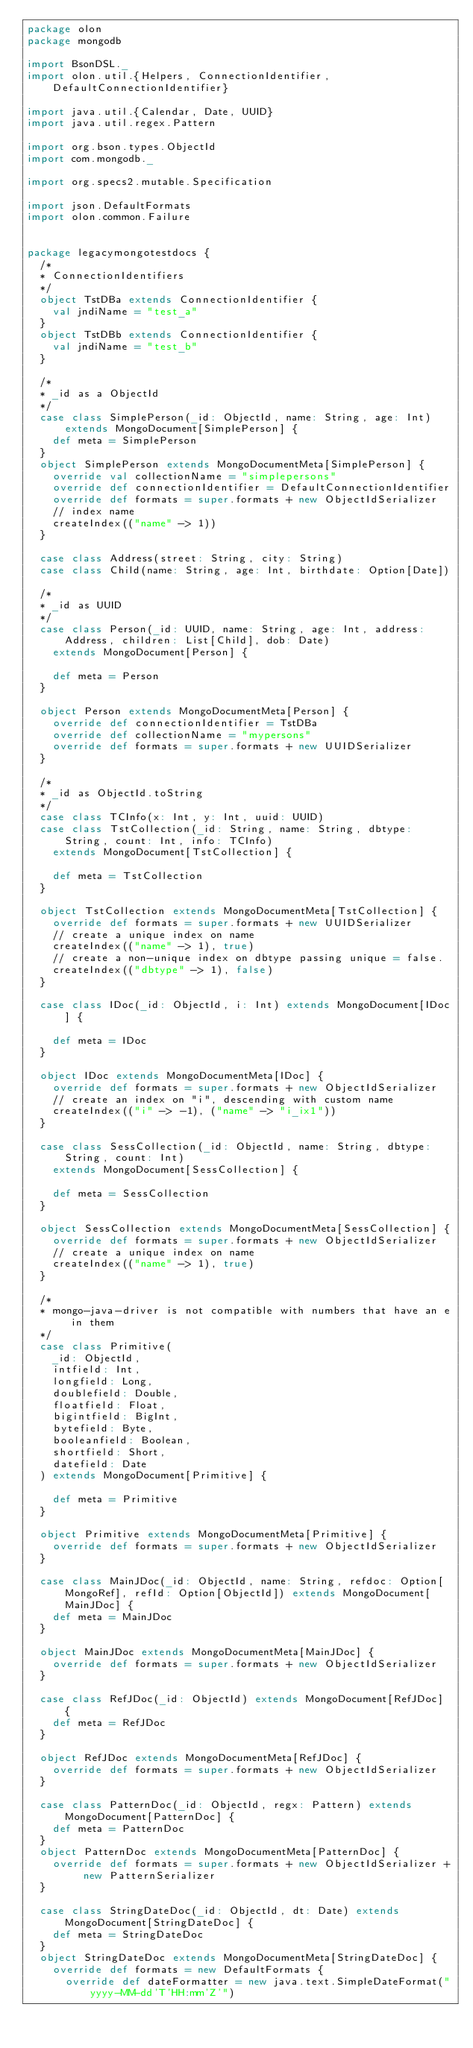<code> <loc_0><loc_0><loc_500><loc_500><_Scala_>package olon
package mongodb

import BsonDSL._
import olon.util.{Helpers, ConnectionIdentifier, DefaultConnectionIdentifier}

import java.util.{Calendar, Date, UUID}
import java.util.regex.Pattern

import org.bson.types.ObjectId
import com.mongodb._

import org.specs2.mutable.Specification

import json.DefaultFormats
import olon.common.Failure


package legacymongotestdocs {
  /*
  * ConnectionIdentifiers
  */
  object TstDBa extends ConnectionIdentifier {
    val jndiName = "test_a"
  }
  object TstDBb extends ConnectionIdentifier {
    val jndiName = "test_b"
  }

  /*
  * _id as a ObjectId
  */
  case class SimplePerson(_id: ObjectId, name: String, age: Int) extends MongoDocument[SimplePerson] {
    def meta = SimplePerson
  }
  object SimplePerson extends MongoDocumentMeta[SimplePerson] {
    override val collectionName = "simplepersons"
    override def connectionIdentifier = DefaultConnectionIdentifier
    override def formats = super.formats + new ObjectIdSerializer
    // index name
    createIndex(("name" -> 1))
  }

  case class Address(street: String, city: String)
  case class Child(name: String, age: Int, birthdate: Option[Date])

  /*
  * _id as UUID
  */
  case class Person(_id: UUID, name: String, age: Int, address: Address, children: List[Child], dob: Date)
    extends MongoDocument[Person] {

    def meta = Person
  }

  object Person extends MongoDocumentMeta[Person] {
    override def connectionIdentifier = TstDBa
    override def collectionName = "mypersons"
    override def formats = super.formats + new UUIDSerializer
  }

  /*
  * _id as ObjectId.toString
  */
  case class TCInfo(x: Int, y: Int, uuid: UUID)
  case class TstCollection(_id: String, name: String, dbtype: String, count: Int, info: TCInfo)
    extends MongoDocument[TstCollection] {

    def meta = TstCollection
  }

  object TstCollection extends MongoDocumentMeta[TstCollection] {
    override def formats = super.formats + new UUIDSerializer
    // create a unique index on name
    createIndex(("name" -> 1), true)
    // create a non-unique index on dbtype passing unique = false.
    createIndex(("dbtype" -> 1), false)
  }

  case class IDoc(_id: ObjectId, i: Int) extends MongoDocument[IDoc] {

    def meta = IDoc
  }

  object IDoc extends MongoDocumentMeta[IDoc] {
    override def formats = super.formats + new ObjectIdSerializer
    // create an index on "i", descending with custom name
    createIndex(("i" -> -1), ("name" -> "i_ix1"))
  }

  case class SessCollection(_id: ObjectId, name: String, dbtype: String, count: Int)
    extends MongoDocument[SessCollection] {

    def meta = SessCollection
  }

  object SessCollection extends MongoDocumentMeta[SessCollection] {
    override def formats = super.formats + new ObjectIdSerializer
    // create a unique index on name
    createIndex(("name" -> 1), true)
  }

  /*
  * mongo-java-driver is not compatible with numbers that have an e in them
  */
  case class Primitive(
    _id: ObjectId,
    intfield: Int,
    longfield: Long,
    doublefield: Double,
    floatfield: Float,
    bigintfield: BigInt,
    bytefield: Byte,
    booleanfield: Boolean,
    shortfield: Short,
    datefield: Date
  ) extends MongoDocument[Primitive] {

    def meta = Primitive
  }

  object Primitive extends MongoDocumentMeta[Primitive] {
    override def formats = super.formats + new ObjectIdSerializer
  }

  case class MainJDoc(_id: ObjectId, name: String, refdoc: Option[MongoRef], refId: Option[ObjectId]) extends MongoDocument[MainJDoc] {
    def meta = MainJDoc
  }

  object MainJDoc extends MongoDocumentMeta[MainJDoc] {
    override def formats = super.formats + new ObjectIdSerializer
  }

  case class RefJDoc(_id: ObjectId) extends MongoDocument[RefJDoc] {
    def meta = RefJDoc
  }

  object RefJDoc extends MongoDocumentMeta[RefJDoc] {
    override def formats = super.formats + new ObjectIdSerializer
  }

  case class PatternDoc(_id: ObjectId, regx: Pattern) extends MongoDocument[PatternDoc] {
    def meta = PatternDoc
  }
  object PatternDoc extends MongoDocumentMeta[PatternDoc] {
    override def formats = super.formats + new ObjectIdSerializer + new PatternSerializer
  }

  case class StringDateDoc(_id: ObjectId, dt: Date) extends MongoDocument[StringDateDoc] {
    def meta = StringDateDoc
  }
  object StringDateDoc extends MongoDocumentMeta[StringDateDoc] {
    override def formats = new DefaultFormats {
      override def dateFormatter = new java.text.SimpleDateFormat("yyyy-MM-dd'T'HH:mm'Z'")</code> 